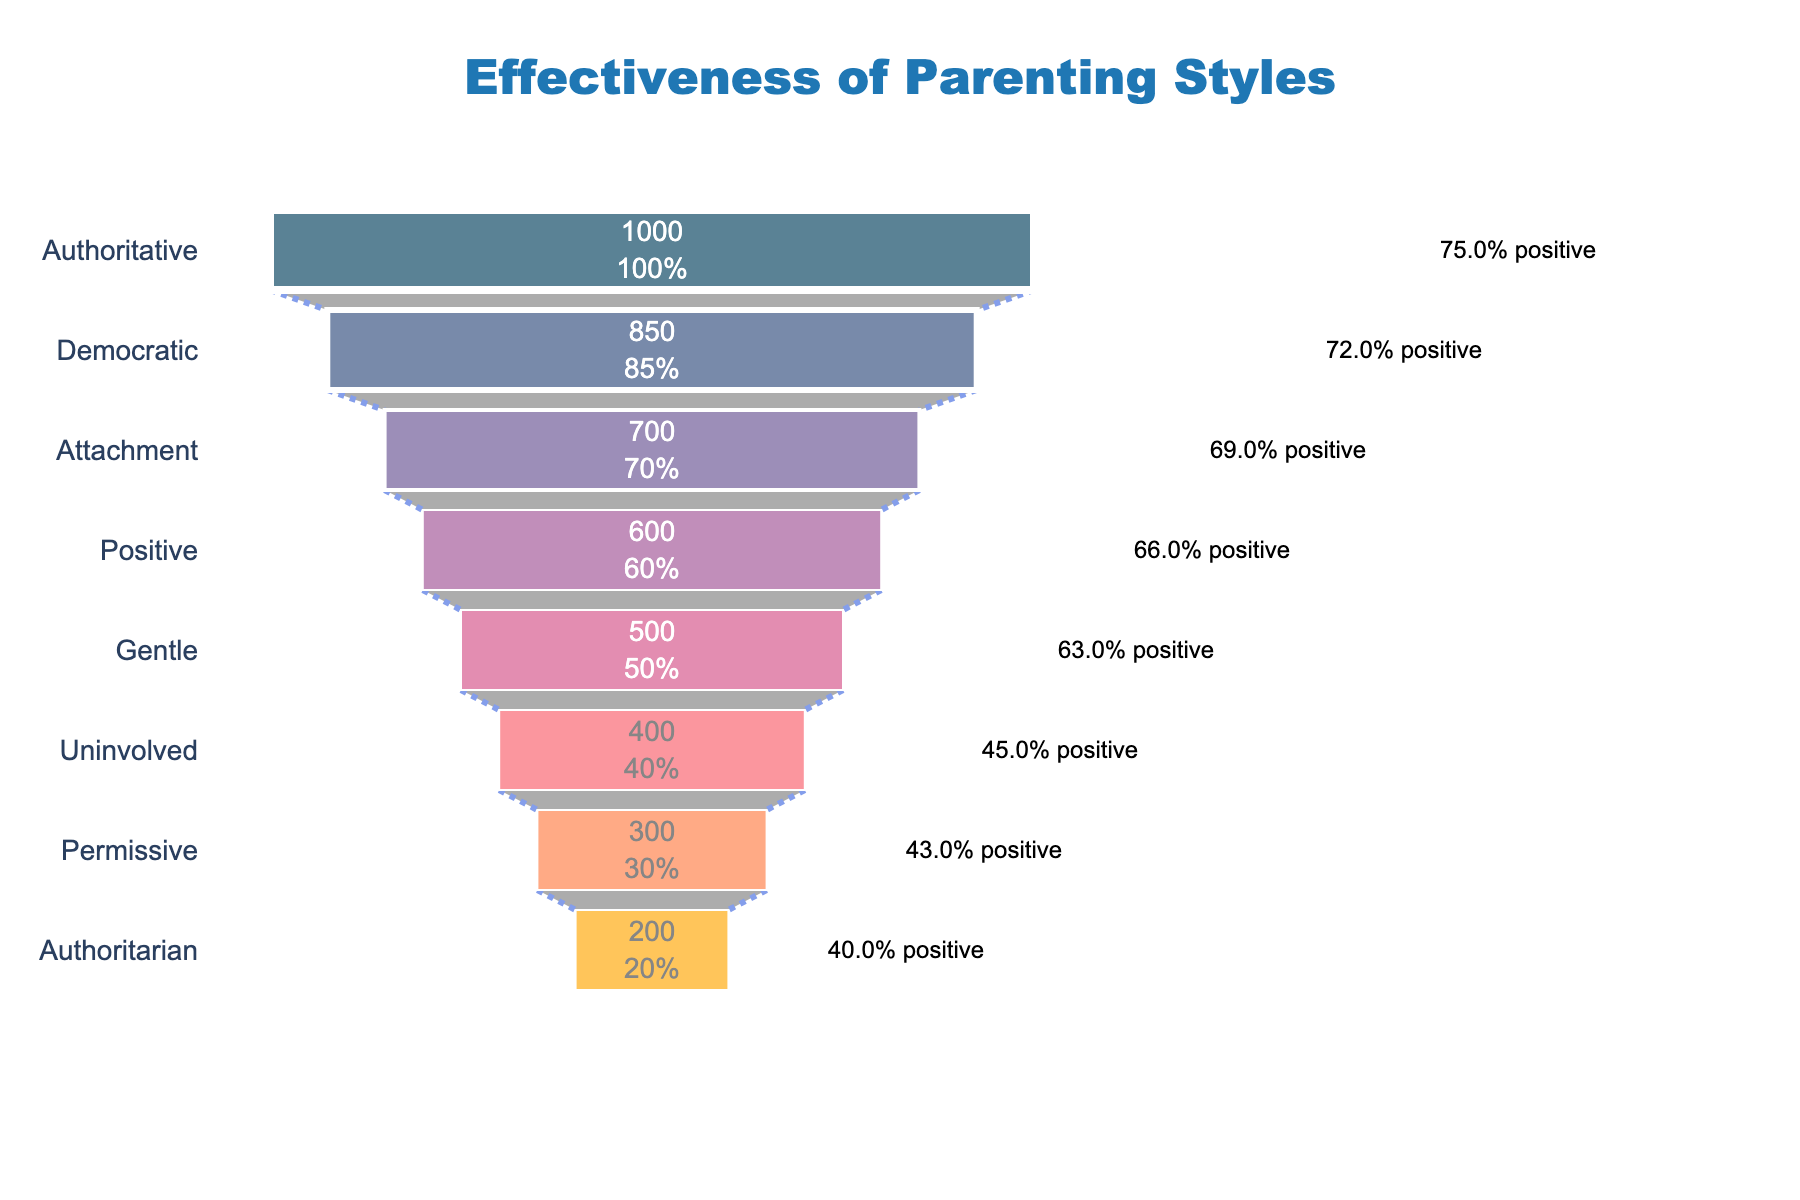what is the title of the figure? The title of the figure can be found at the top of the chart. It provides a brief description of the data represented in the chart. In this case, the title is "Effectiveness of Parenting Styles".
Answer: Effectiveness of Parenting Styles How many different parenting styles are illustrated in the chart? To determine the number of different parenting styles shown, count the distinct entries on the y-axis of the funnel chart.
Answer: 8 Which parenting style studied the most children? Look for the parenting style with the highest value indicated on the x-axis. According to the chart, the parenting style that studied the most children is "Authoritative".
Answer: Authoritative What percentage of positive behavioral outcomes did children from the democratic parenting style exhibit? Find the annotation next to "Democratic" parenting style on the chart, which indicates the percentage of positive behavioral outcomes.
Answer: 72% Which parenting style has the lowest percentage of positive behavioral outcomes? Identify the parenting style with the smallest percentage of positive outcomes, denoted by the annotations next to each parenting style. "Authoritarian" has the lowest percentage, showing 40% positive outcomes.
Answer: Authoritarian How much lower is the number of children studied under permissive parenting compared to attachment parenting? Subtract the number of children studied under permissive parenting from the number of children studied under attachment parenting: 700 (Attachment) - 300 (Permissive) = 400.
Answer: 400 Between gentle and positive parenting styles, which one achieved a higher number of positive behavioral outcomes and by how much? Compare the positive behavioral outcomes of both parenting styles: Gentle (315) and Positive (396). The difference is 396 - 315 = 81.
Answer: Positive achieved 81 more outcomes What is the average number of children studied across all parenting styles? Sum the number of children studied across all parenting styles and divide by the number of styles: (1000 + 850 + 700 + 600 + 500 + 400 + 300 + 200) / 8 = 568.75.
Answer: 568.75 Which parenting style exhibited the highest percentage of positive behavioral outcomes? Look for the highest percentage annotation next to the parenting style. The "Authoritative" parenting style shows the highest percentage of 75% positive outcomes.
Answer: Authoritative How many more children exhibited positive behavioral outcomes under authoritative parenting compared to authoritarian parenting? Subtract the positive behavioral outcomes of authoritarian parenting from that of authoritative parenting: 750 (Authoritative) - 80 (Authoritarian) = 670.
Answer: 670 